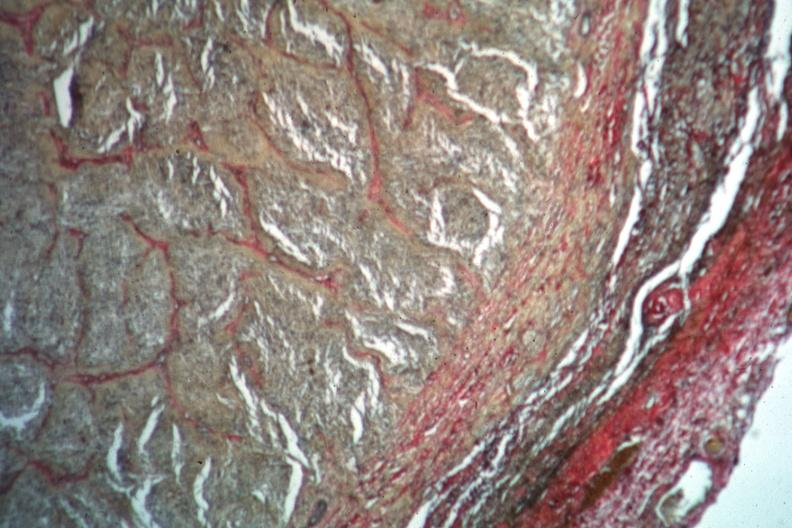what is present?
Answer the question using a single word or phrase. Optic nerve 